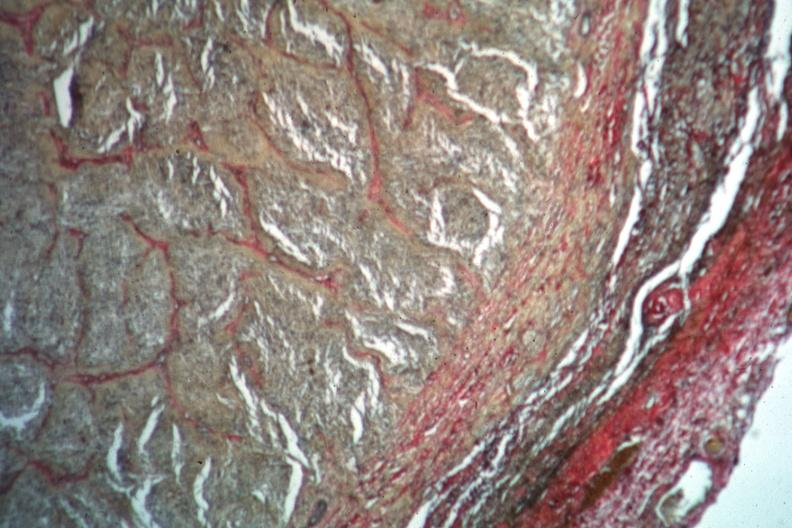what is present?
Answer the question using a single word or phrase. Optic nerve 